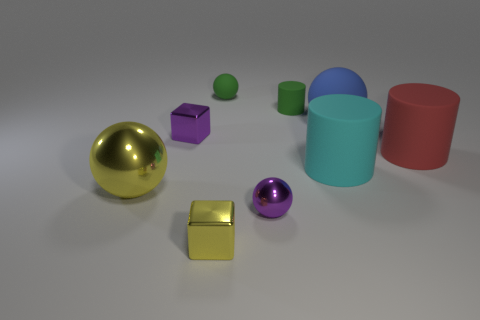Is the shape of the large cyan object the same as the blue thing?
Give a very brief answer. No. What number of other things are the same size as the purple metal sphere?
Your response must be concise. 4. What size is the cyan rubber cylinder?
Your response must be concise. Large. What number of things have the same size as the cyan rubber cylinder?
Give a very brief answer. 3. There is a small purple thing that is the same shape as the large blue rubber object; what material is it?
Your answer should be very brief. Metal. What color is the rubber object that is to the right of the large blue matte ball?
Your answer should be very brief. Red. Are there more purple metallic spheres that are in front of the tiny purple metallic ball than tiny gray rubber spheres?
Offer a very short reply. No. The big shiny object is what color?
Provide a succinct answer. Yellow. What is the shape of the small shiny object that is to the right of the tiny sphere behind the large cyan rubber cylinder left of the blue sphere?
Your answer should be very brief. Sphere. There is a small thing that is both in front of the small green cylinder and behind the tiny purple shiny sphere; what material is it?
Provide a short and direct response. Metal. 